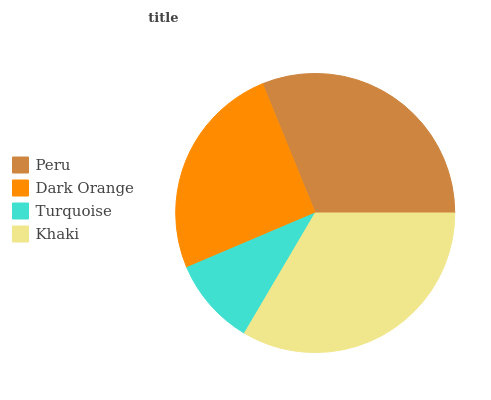Is Turquoise the minimum?
Answer yes or no. Yes. Is Khaki the maximum?
Answer yes or no. Yes. Is Dark Orange the minimum?
Answer yes or no. No. Is Dark Orange the maximum?
Answer yes or no. No. Is Peru greater than Dark Orange?
Answer yes or no. Yes. Is Dark Orange less than Peru?
Answer yes or no. Yes. Is Dark Orange greater than Peru?
Answer yes or no. No. Is Peru less than Dark Orange?
Answer yes or no. No. Is Peru the high median?
Answer yes or no. Yes. Is Dark Orange the low median?
Answer yes or no. Yes. Is Khaki the high median?
Answer yes or no. No. Is Turquoise the low median?
Answer yes or no. No. 